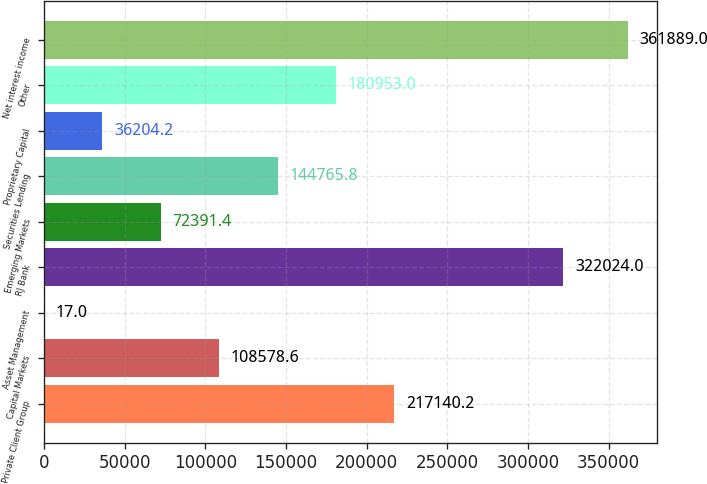Convert chart to OTSL. <chart><loc_0><loc_0><loc_500><loc_500><bar_chart><fcel>Private Client Group<fcel>Capital Markets<fcel>Asset Management<fcel>RJ Bank<fcel>Emerging Markets<fcel>Securities Lending<fcel>Proprietary Capital<fcel>Other<fcel>Net interest income<nl><fcel>217140<fcel>108579<fcel>17<fcel>322024<fcel>72391.4<fcel>144766<fcel>36204.2<fcel>180953<fcel>361889<nl></chart> 